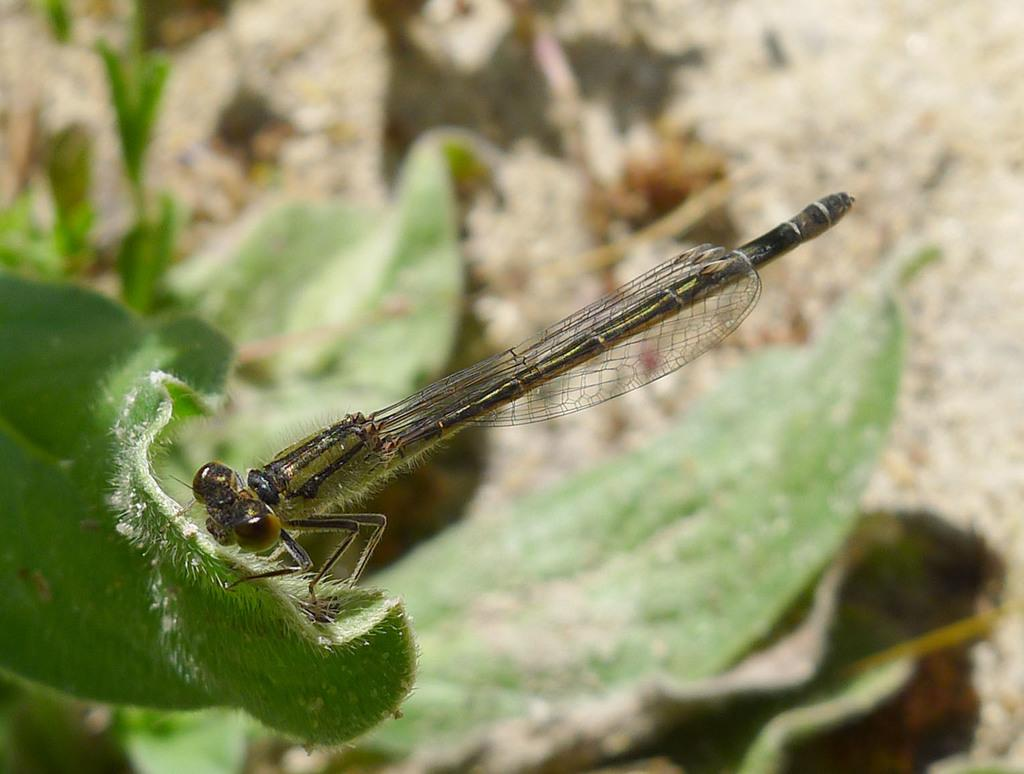What is present on the leaf in the image? There is an insect in the leaf in the image. What can be seen at the bottom of the image? The ground is visible at the bottom of the image. What type of cough medicine is recommended for the insect in the image? There is no mention of a cough or any need for medicine in the image; it simply shows an insect on a leaf. 